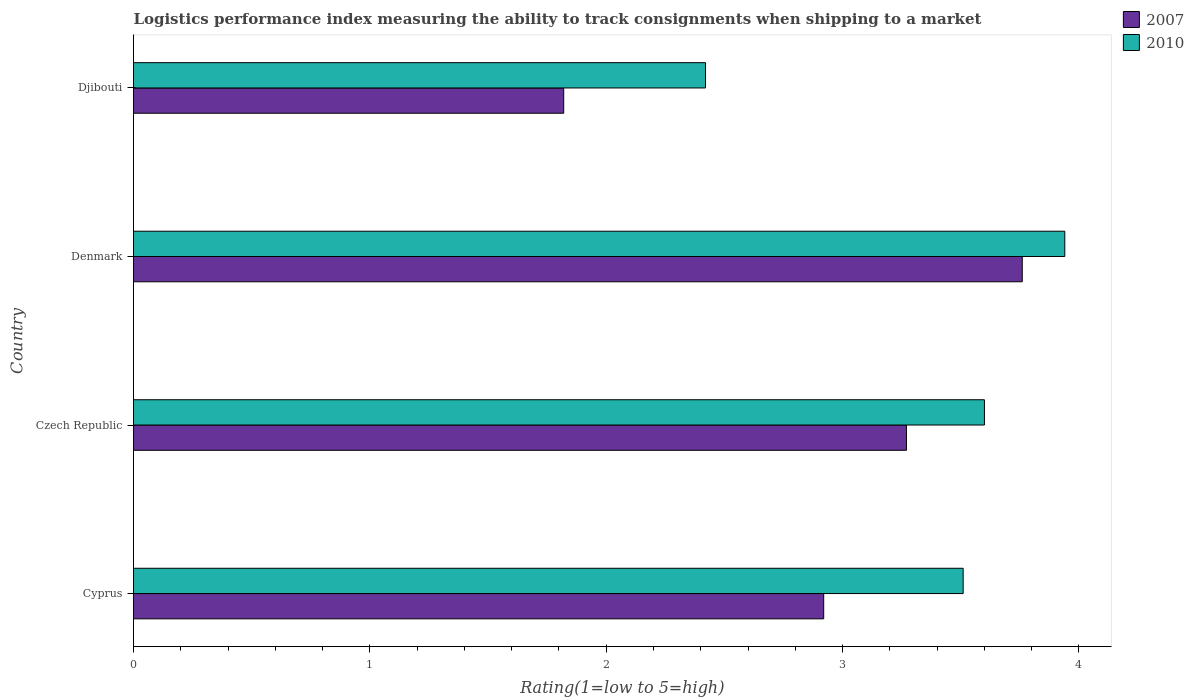How many different coloured bars are there?
Give a very brief answer. 2. Are the number of bars on each tick of the Y-axis equal?
Provide a succinct answer. Yes. How many bars are there on the 3rd tick from the bottom?
Make the answer very short. 2. What is the label of the 4th group of bars from the top?
Your answer should be compact. Cyprus. In how many cases, is the number of bars for a given country not equal to the number of legend labels?
Your answer should be very brief. 0. What is the Logistic performance index in 2010 in Djibouti?
Provide a succinct answer. 2.42. Across all countries, what is the maximum Logistic performance index in 2010?
Make the answer very short. 3.94. Across all countries, what is the minimum Logistic performance index in 2010?
Give a very brief answer. 2.42. In which country was the Logistic performance index in 2007 maximum?
Provide a succinct answer. Denmark. In which country was the Logistic performance index in 2007 minimum?
Offer a very short reply. Djibouti. What is the total Logistic performance index in 2007 in the graph?
Provide a succinct answer. 11.77. What is the difference between the Logistic performance index in 2010 in Czech Republic and that in Djibouti?
Provide a short and direct response. 1.18. What is the difference between the Logistic performance index in 2007 in Djibouti and the Logistic performance index in 2010 in Denmark?
Provide a succinct answer. -2.12. What is the average Logistic performance index in 2007 per country?
Your answer should be very brief. 2.94. What is the difference between the Logistic performance index in 2007 and Logistic performance index in 2010 in Cyprus?
Ensure brevity in your answer.  -0.59. In how many countries, is the Logistic performance index in 2007 greater than 1.8 ?
Provide a short and direct response. 4. What is the ratio of the Logistic performance index in 2010 in Czech Republic to that in Denmark?
Offer a terse response. 0.91. Is the difference between the Logistic performance index in 2007 in Czech Republic and Denmark greater than the difference between the Logistic performance index in 2010 in Czech Republic and Denmark?
Your answer should be very brief. No. What is the difference between the highest and the second highest Logistic performance index in 2007?
Ensure brevity in your answer.  0.49. What is the difference between the highest and the lowest Logistic performance index in 2007?
Provide a succinct answer. 1.94. Is the sum of the Logistic performance index in 2010 in Denmark and Djibouti greater than the maximum Logistic performance index in 2007 across all countries?
Offer a terse response. Yes. What does the 1st bar from the top in Czech Republic represents?
Ensure brevity in your answer.  2010. How many bars are there?
Ensure brevity in your answer.  8. Are all the bars in the graph horizontal?
Offer a terse response. Yes. What is the difference between two consecutive major ticks on the X-axis?
Give a very brief answer. 1. Are the values on the major ticks of X-axis written in scientific E-notation?
Your answer should be very brief. No. Does the graph contain any zero values?
Give a very brief answer. No. Does the graph contain grids?
Keep it short and to the point. No. How many legend labels are there?
Keep it short and to the point. 2. How are the legend labels stacked?
Provide a short and direct response. Vertical. What is the title of the graph?
Provide a succinct answer. Logistics performance index measuring the ability to track consignments when shipping to a market. Does "1978" appear as one of the legend labels in the graph?
Your answer should be compact. No. What is the label or title of the X-axis?
Your response must be concise. Rating(1=low to 5=high). What is the Rating(1=low to 5=high) in 2007 in Cyprus?
Offer a terse response. 2.92. What is the Rating(1=low to 5=high) in 2010 in Cyprus?
Ensure brevity in your answer.  3.51. What is the Rating(1=low to 5=high) of 2007 in Czech Republic?
Provide a succinct answer. 3.27. What is the Rating(1=low to 5=high) in 2007 in Denmark?
Your response must be concise. 3.76. What is the Rating(1=low to 5=high) in 2010 in Denmark?
Your answer should be compact. 3.94. What is the Rating(1=low to 5=high) of 2007 in Djibouti?
Offer a terse response. 1.82. What is the Rating(1=low to 5=high) in 2010 in Djibouti?
Provide a succinct answer. 2.42. Across all countries, what is the maximum Rating(1=low to 5=high) in 2007?
Make the answer very short. 3.76. Across all countries, what is the maximum Rating(1=low to 5=high) of 2010?
Your response must be concise. 3.94. Across all countries, what is the minimum Rating(1=low to 5=high) in 2007?
Provide a short and direct response. 1.82. Across all countries, what is the minimum Rating(1=low to 5=high) in 2010?
Your response must be concise. 2.42. What is the total Rating(1=low to 5=high) of 2007 in the graph?
Offer a terse response. 11.77. What is the total Rating(1=low to 5=high) in 2010 in the graph?
Provide a succinct answer. 13.47. What is the difference between the Rating(1=low to 5=high) in 2007 in Cyprus and that in Czech Republic?
Your answer should be very brief. -0.35. What is the difference between the Rating(1=low to 5=high) in 2010 in Cyprus and that in Czech Republic?
Offer a terse response. -0.09. What is the difference between the Rating(1=low to 5=high) in 2007 in Cyprus and that in Denmark?
Your answer should be compact. -0.84. What is the difference between the Rating(1=low to 5=high) in 2010 in Cyprus and that in Denmark?
Your answer should be very brief. -0.43. What is the difference between the Rating(1=low to 5=high) in 2007 in Cyprus and that in Djibouti?
Keep it short and to the point. 1.1. What is the difference between the Rating(1=low to 5=high) of 2010 in Cyprus and that in Djibouti?
Your answer should be compact. 1.09. What is the difference between the Rating(1=low to 5=high) of 2007 in Czech Republic and that in Denmark?
Offer a terse response. -0.49. What is the difference between the Rating(1=low to 5=high) in 2010 in Czech Republic and that in Denmark?
Ensure brevity in your answer.  -0.34. What is the difference between the Rating(1=low to 5=high) of 2007 in Czech Republic and that in Djibouti?
Offer a very short reply. 1.45. What is the difference between the Rating(1=low to 5=high) of 2010 in Czech Republic and that in Djibouti?
Provide a short and direct response. 1.18. What is the difference between the Rating(1=low to 5=high) in 2007 in Denmark and that in Djibouti?
Give a very brief answer. 1.94. What is the difference between the Rating(1=low to 5=high) of 2010 in Denmark and that in Djibouti?
Make the answer very short. 1.52. What is the difference between the Rating(1=low to 5=high) of 2007 in Cyprus and the Rating(1=low to 5=high) of 2010 in Czech Republic?
Provide a succinct answer. -0.68. What is the difference between the Rating(1=low to 5=high) of 2007 in Cyprus and the Rating(1=low to 5=high) of 2010 in Denmark?
Make the answer very short. -1.02. What is the difference between the Rating(1=low to 5=high) in 2007 in Czech Republic and the Rating(1=low to 5=high) in 2010 in Denmark?
Offer a very short reply. -0.67. What is the difference between the Rating(1=low to 5=high) of 2007 in Czech Republic and the Rating(1=low to 5=high) of 2010 in Djibouti?
Make the answer very short. 0.85. What is the difference between the Rating(1=low to 5=high) in 2007 in Denmark and the Rating(1=low to 5=high) in 2010 in Djibouti?
Ensure brevity in your answer.  1.34. What is the average Rating(1=low to 5=high) of 2007 per country?
Offer a terse response. 2.94. What is the average Rating(1=low to 5=high) in 2010 per country?
Provide a succinct answer. 3.37. What is the difference between the Rating(1=low to 5=high) of 2007 and Rating(1=low to 5=high) of 2010 in Cyprus?
Provide a short and direct response. -0.59. What is the difference between the Rating(1=low to 5=high) of 2007 and Rating(1=low to 5=high) of 2010 in Czech Republic?
Provide a short and direct response. -0.33. What is the difference between the Rating(1=low to 5=high) in 2007 and Rating(1=low to 5=high) in 2010 in Denmark?
Make the answer very short. -0.18. What is the ratio of the Rating(1=low to 5=high) of 2007 in Cyprus to that in Czech Republic?
Offer a very short reply. 0.89. What is the ratio of the Rating(1=low to 5=high) of 2007 in Cyprus to that in Denmark?
Keep it short and to the point. 0.78. What is the ratio of the Rating(1=low to 5=high) in 2010 in Cyprus to that in Denmark?
Offer a very short reply. 0.89. What is the ratio of the Rating(1=low to 5=high) in 2007 in Cyprus to that in Djibouti?
Keep it short and to the point. 1.6. What is the ratio of the Rating(1=low to 5=high) of 2010 in Cyprus to that in Djibouti?
Offer a terse response. 1.45. What is the ratio of the Rating(1=low to 5=high) of 2007 in Czech Republic to that in Denmark?
Offer a terse response. 0.87. What is the ratio of the Rating(1=low to 5=high) in 2010 in Czech Republic to that in Denmark?
Keep it short and to the point. 0.91. What is the ratio of the Rating(1=low to 5=high) in 2007 in Czech Republic to that in Djibouti?
Make the answer very short. 1.8. What is the ratio of the Rating(1=low to 5=high) in 2010 in Czech Republic to that in Djibouti?
Give a very brief answer. 1.49. What is the ratio of the Rating(1=low to 5=high) in 2007 in Denmark to that in Djibouti?
Your answer should be very brief. 2.07. What is the ratio of the Rating(1=low to 5=high) in 2010 in Denmark to that in Djibouti?
Your response must be concise. 1.63. What is the difference between the highest and the second highest Rating(1=low to 5=high) in 2007?
Ensure brevity in your answer.  0.49. What is the difference between the highest and the second highest Rating(1=low to 5=high) of 2010?
Your answer should be very brief. 0.34. What is the difference between the highest and the lowest Rating(1=low to 5=high) of 2007?
Your answer should be compact. 1.94. What is the difference between the highest and the lowest Rating(1=low to 5=high) in 2010?
Ensure brevity in your answer.  1.52. 